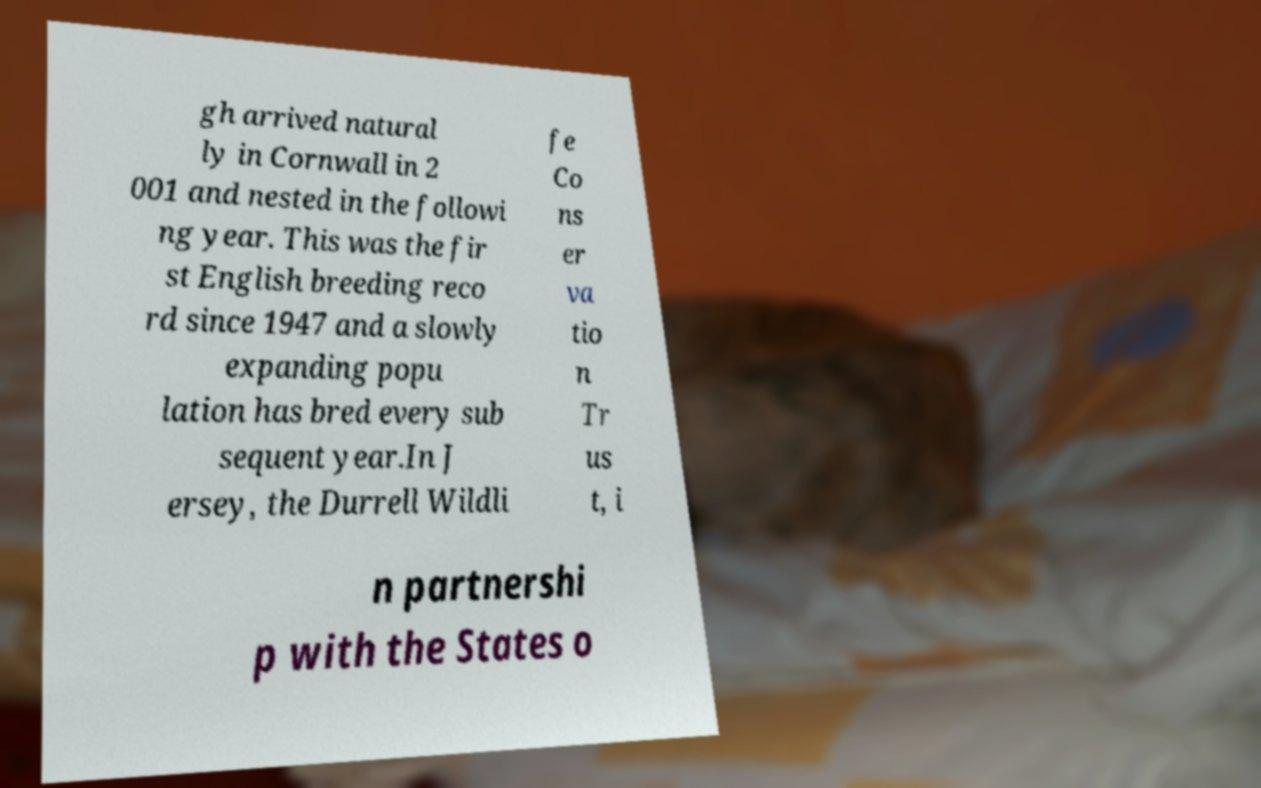Please read and relay the text visible in this image. What does it say? gh arrived natural ly in Cornwall in 2 001 and nested in the followi ng year. This was the fir st English breeding reco rd since 1947 and a slowly expanding popu lation has bred every sub sequent year.In J ersey, the Durrell Wildli fe Co ns er va tio n Tr us t, i n partnershi p with the States o 